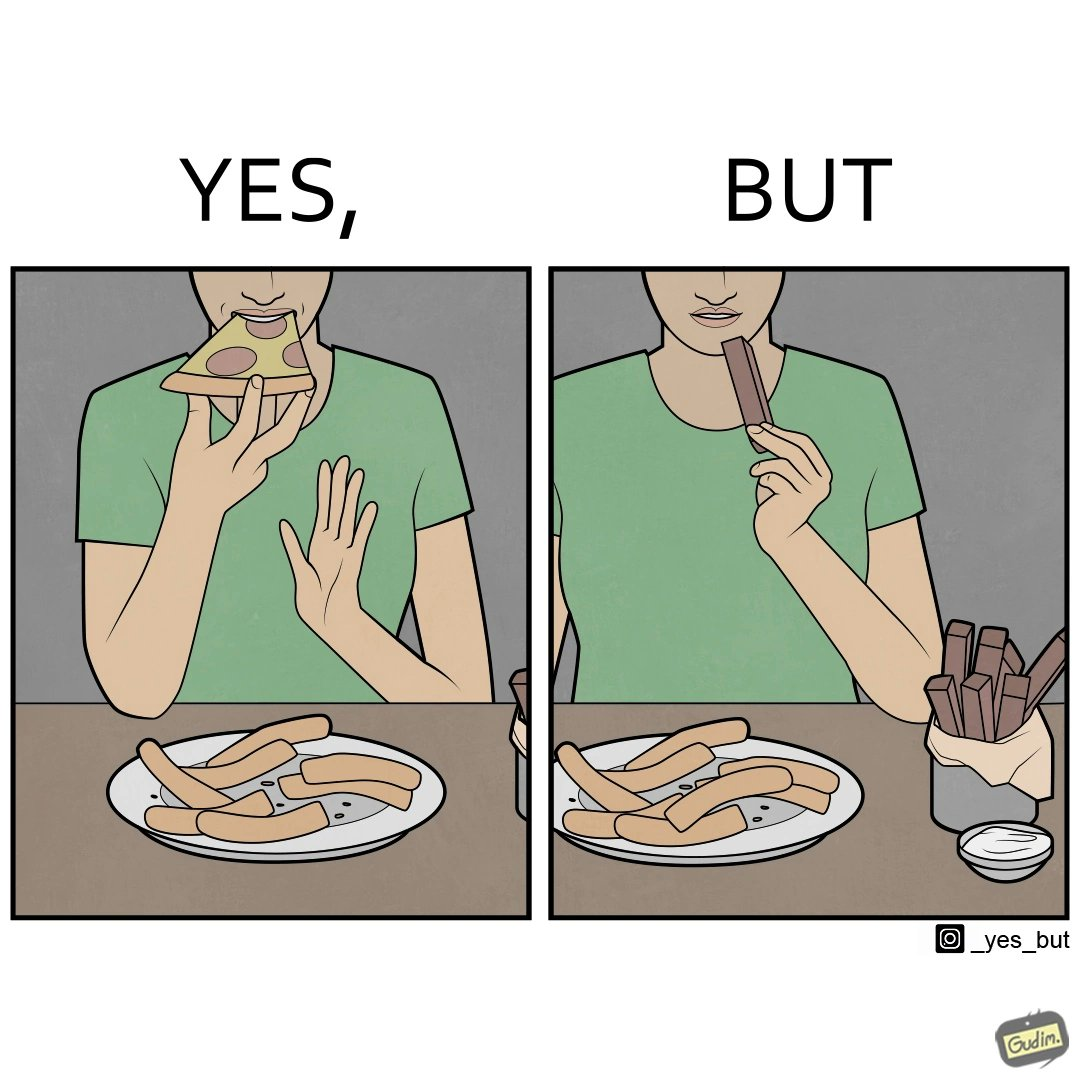What is shown in this image? the irony in this image is that people waste pizza crust by saying that it is too hard, while they eat hard chocolate without any complaints 